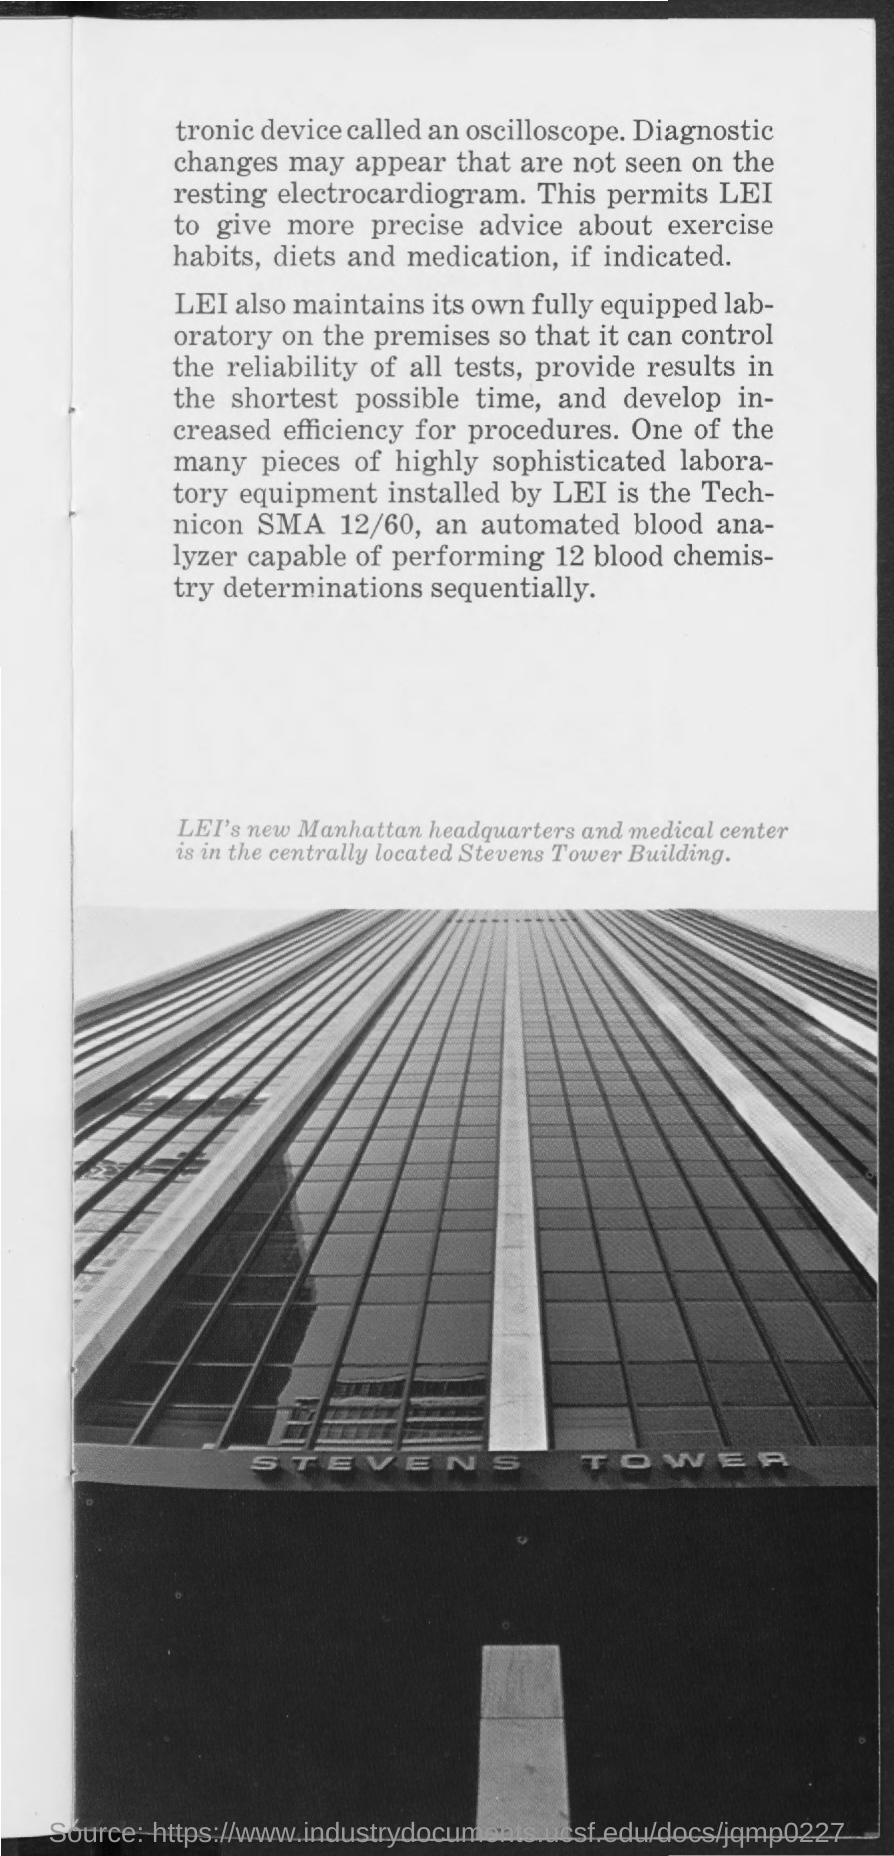How many blood chemistry determinations can be performed by Technicon?
Ensure brevity in your answer.  12. In which building is LEI's new Manhattan Headquarters and medical center?
Offer a very short reply. Stevens Tower. 